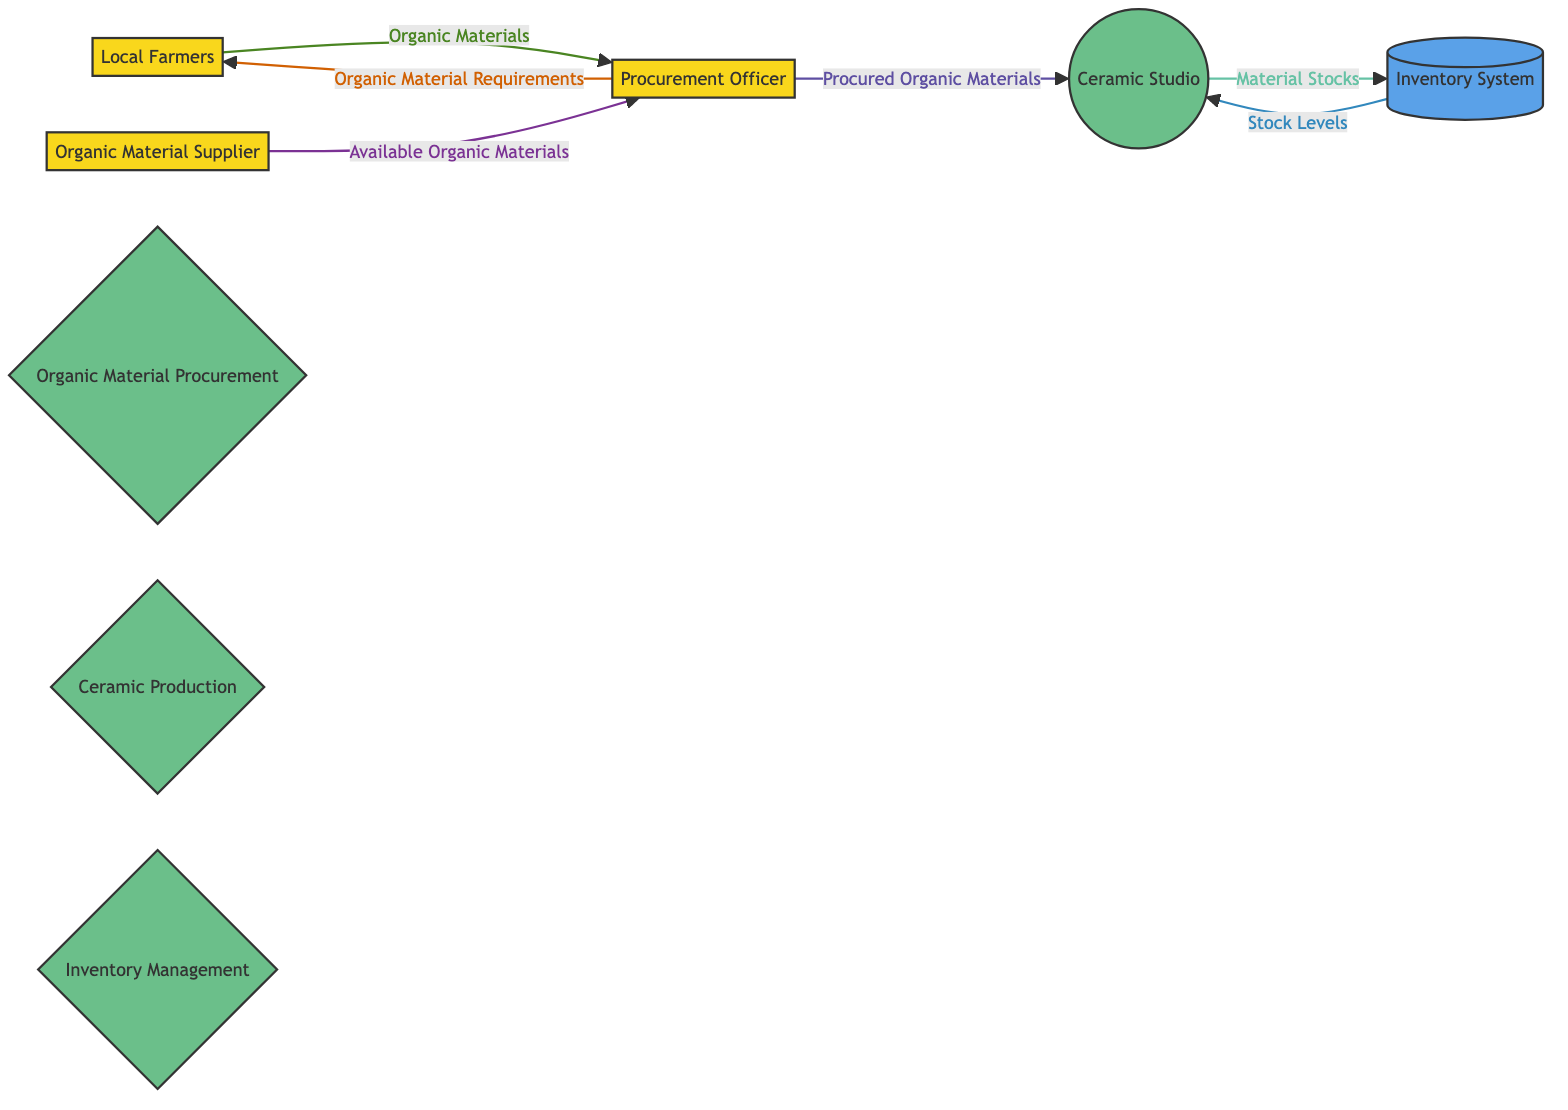What are the two external entities involved in procurement? The diagram includes Local Farmers and Organic Material Supplier as external entities involved in the procurement process.
Answer: Local Farmers, Organic Material Supplier How many processes are present in the diagram? The diagram shows a total of three processes: Organic Material Procurement, Ceramic Production, and Inventory Management.
Answer: 3 What data does the Procurement Officer send to Local Farmers? The Procurement Officer sends Organic Material Requirements to Local Farmers. This flow of information indicates a request for specific organic materials.
Answer: Organic Material Requirements What does the Ceramic Studio update in the Inventory System? The Ceramic Studio updates Material Stocks in the Inventory System, which keeps track of the quantities of organic materials available for firing.
Answer: Material Stocks What data does the Inventory System provide to the Ceramic Studio? The Inventory System provides Stock Levels to the Ceramic Studio, allowing the studio to know the current availability of organic materials.
Answer: Stock Levels Which entity receives Available Organic Materials from the Organic Material Supplier? The Procurement Officer receives Available Organic Materials as this entity is responsible for sourcing and evaluating materials for procurement.
Answer: Procurement Officer What is the main activity involved in the Organic Material Procurement process? The main activity in the Organic Material Procurement process is the sourcing and acquiring of organic materials necessary for ceramic firing.
Answer: Sourcing and acquiring organic materials How does the flow of information between the Procurement Officer and Local Farmers start? The information flow between the Procurement Officer and Local Farmers starts when the Procurement Officer sends Organic Material Requirements to the farmers, requesting specific materials needed for the process.
Answer: Organic Material Requirements What role does the Inventory System play in the overall process? The Inventory System functions as a data store that manages and tracks the stock levels of organic materials, ensuring that the Ceramic Studio has access to the necessary materials when needed.
Answer: Data store for stock levels 